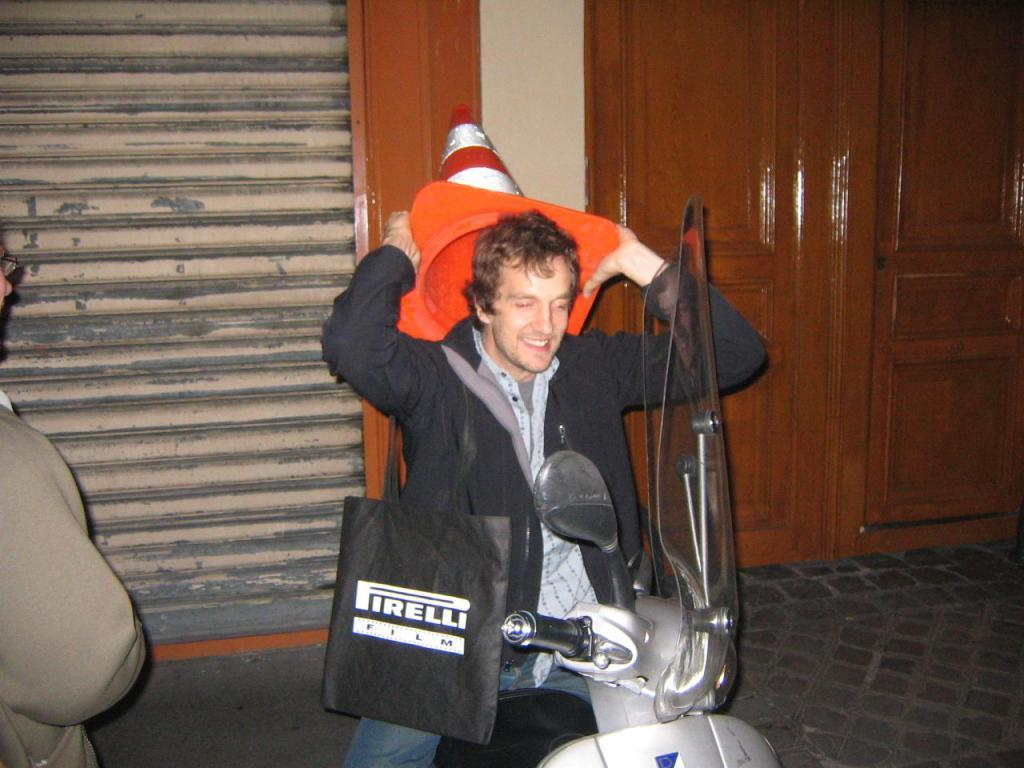What is the man in the image doing? The man is seated on a scooter in the image. What is the man wearing? The man is wearing a bag. What is the man holding in his hands? The man is holding a cone in his hands. What type of structure can be seen in the image? There is a house in the image. Can you describe the position of the man standing in the image? There is a man standing on the side in the image. What part of the house is visible in the image? There is a door visible in the image. How many mailboxes are present in the image? There are no mailboxes visible in the image. How many men named John are present in the image? The provided facts do not mention any names, so we cannot determine how many men named John are present in the image. 